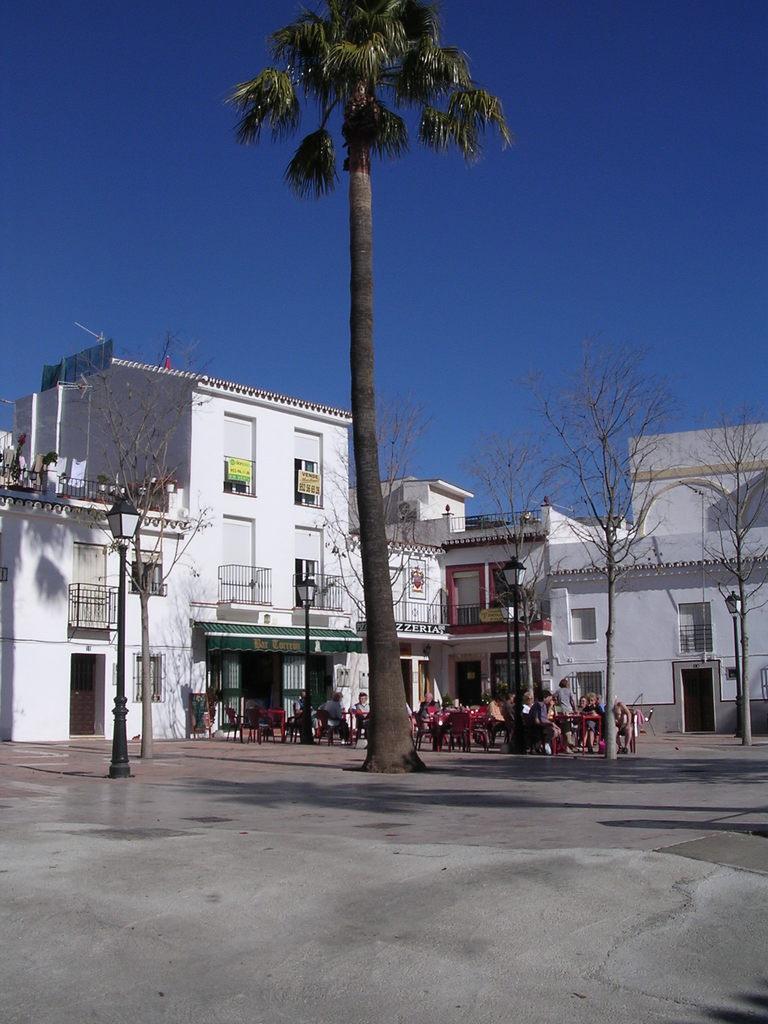How would you summarize this image in a sentence or two? In this picture we can see a tall tree in the middle and in the background we have many houses, trees and people sitting on chairs. 